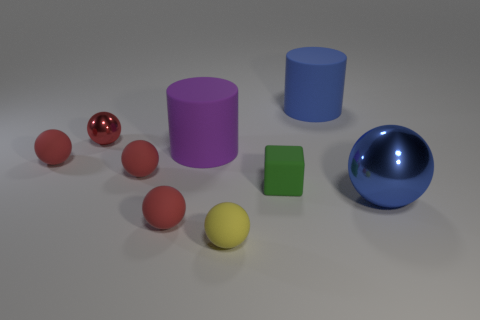Subtract all red spheres. How many were subtracted if there are1red spheres left? 3 Subtract all small balls. How many balls are left? 1 Subtract all cyan cylinders. How many red balls are left? 4 Subtract all blue balls. How many balls are left? 5 Subtract 3 spheres. How many spheres are left? 3 Add 1 small blocks. How many objects exist? 10 Subtract all cylinders. How many objects are left? 7 Add 5 tiny red metallic things. How many tiny red metallic things are left? 6 Add 9 blue shiny objects. How many blue shiny objects exist? 10 Subtract 0 brown blocks. How many objects are left? 9 